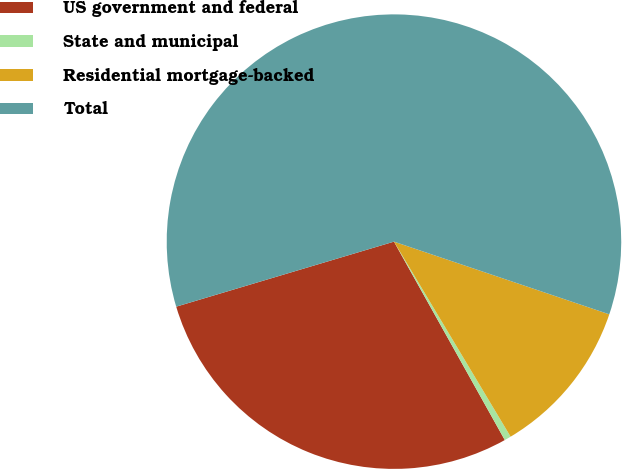<chart> <loc_0><loc_0><loc_500><loc_500><pie_chart><fcel>US government and federal<fcel>State and municipal<fcel>Residential mortgage-backed<fcel>Total<nl><fcel>28.49%<fcel>0.47%<fcel>11.24%<fcel>59.8%<nl></chart> 